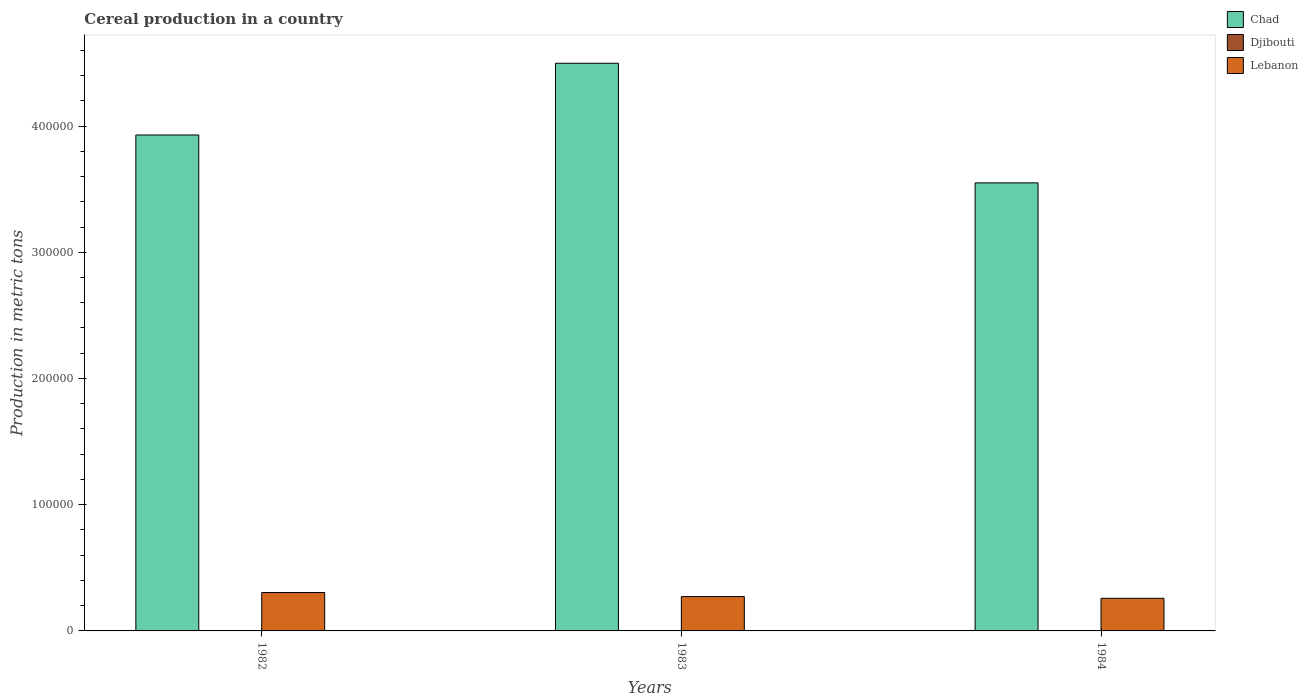How many groups of bars are there?
Provide a short and direct response. 3. Are the number of bars on each tick of the X-axis equal?
Offer a very short reply. Yes. What is the label of the 2nd group of bars from the left?
Give a very brief answer. 1983. What is the total cereal production in Chad in 1984?
Make the answer very short. 3.55e+05. Across all years, what is the maximum total cereal production in Djibouti?
Give a very brief answer. 7. What is the total total cereal production in Djibouti in the graph?
Your answer should be very brief. 17. What is the difference between the total cereal production in Chad in 1983 and that in 1984?
Make the answer very short. 9.48e+04. What is the difference between the total cereal production in Chad in 1982 and the total cereal production in Lebanon in 1983?
Your answer should be very brief. 3.66e+05. What is the average total cereal production in Chad per year?
Give a very brief answer. 3.99e+05. In the year 1982, what is the difference between the total cereal production in Chad and total cereal production in Djibouti?
Give a very brief answer. 3.93e+05. In how many years, is the total cereal production in Djibouti greater than 120000 metric tons?
Your response must be concise. 0. What is the ratio of the total cereal production in Chad in 1982 to that in 1984?
Your answer should be very brief. 1.11. What is the difference between the highest and the second highest total cereal production in Chad?
Give a very brief answer. 5.68e+04. What is the difference between the highest and the lowest total cereal production in Djibouti?
Ensure brevity in your answer.  2. Is the sum of the total cereal production in Chad in 1982 and 1983 greater than the maximum total cereal production in Lebanon across all years?
Keep it short and to the point. Yes. What does the 2nd bar from the left in 1982 represents?
Provide a short and direct response. Djibouti. What does the 2nd bar from the right in 1983 represents?
Ensure brevity in your answer.  Djibouti. Does the graph contain grids?
Make the answer very short. No. What is the title of the graph?
Make the answer very short. Cereal production in a country. What is the label or title of the X-axis?
Your answer should be very brief. Years. What is the label or title of the Y-axis?
Your answer should be very brief. Production in metric tons. What is the Production in metric tons in Chad in 1982?
Provide a short and direct response. 3.93e+05. What is the Production in metric tons in Djibouti in 1982?
Offer a very short reply. 5. What is the Production in metric tons in Lebanon in 1982?
Your response must be concise. 3.04e+04. What is the Production in metric tons of Chad in 1983?
Give a very brief answer. 4.50e+05. What is the Production in metric tons of Djibouti in 1983?
Your answer should be compact. 5. What is the Production in metric tons in Lebanon in 1983?
Keep it short and to the point. 2.72e+04. What is the Production in metric tons of Chad in 1984?
Provide a succinct answer. 3.55e+05. What is the Production in metric tons of Lebanon in 1984?
Make the answer very short. 2.58e+04. Across all years, what is the maximum Production in metric tons of Chad?
Provide a short and direct response. 4.50e+05. Across all years, what is the maximum Production in metric tons in Djibouti?
Ensure brevity in your answer.  7. Across all years, what is the maximum Production in metric tons in Lebanon?
Provide a succinct answer. 3.04e+04. Across all years, what is the minimum Production in metric tons of Chad?
Make the answer very short. 3.55e+05. Across all years, what is the minimum Production in metric tons in Djibouti?
Offer a terse response. 5. Across all years, what is the minimum Production in metric tons of Lebanon?
Provide a succinct answer. 2.58e+04. What is the total Production in metric tons of Chad in the graph?
Your answer should be very brief. 1.20e+06. What is the total Production in metric tons of Djibouti in the graph?
Give a very brief answer. 17. What is the total Production in metric tons of Lebanon in the graph?
Give a very brief answer. 8.35e+04. What is the difference between the Production in metric tons in Chad in 1982 and that in 1983?
Your response must be concise. -5.68e+04. What is the difference between the Production in metric tons in Djibouti in 1982 and that in 1983?
Keep it short and to the point. 0. What is the difference between the Production in metric tons of Lebanon in 1982 and that in 1983?
Keep it short and to the point. 3220. What is the difference between the Production in metric tons of Chad in 1982 and that in 1984?
Ensure brevity in your answer.  3.79e+04. What is the difference between the Production in metric tons of Djibouti in 1982 and that in 1984?
Give a very brief answer. -2. What is the difference between the Production in metric tons of Lebanon in 1982 and that in 1984?
Make the answer very short. 4589. What is the difference between the Production in metric tons of Chad in 1983 and that in 1984?
Offer a very short reply. 9.48e+04. What is the difference between the Production in metric tons of Lebanon in 1983 and that in 1984?
Your answer should be very brief. 1369. What is the difference between the Production in metric tons of Chad in 1982 and the Production in metric tons of Djibouti in 1983?
Provide a short and direct response. 3.93e+05. What is the difference between the Production in metric tons in Chad in 1982 and the Production in metric tons in Lebanon in 1983?
Your answer should be very brief. 3.66e+05. What is the difference between the Production in metric tons of Djibouti in 1982 and the Production in metric tons of Lebanon in 1983?
Ensure brevity in your answer.  -2.72e+04. What is the difference between the Production in metric tons in Chad in 1982 and the Production in metric tons in Djibouti in 1984?
Your answer should be very brief. 3.93e+05. What is the difference between the Production in metric tons in Chad in 1982 and the Production in metric tons in Lebanon in 1984?
Keep it short and to the point. 3.67e+05. What is the difference between the Production in metric tons in Djibouti in 1982 and the Production in metric tons in Lebanon in 1984?
Your answer should be compact. -2.58e+04. What is the difference between the Production in metric tons of Chad in 1983 and the Production in metric tons of Djibouti in 1984?
Provide a succinct answer. 4.50e+05. What is the difference between the Production in metric tons of Chad in 1983 and the Production in metric tons of Lebanon in 1984?
Your response must be concise. 4.24e+05. What is the difference between the Production in metric tons in Djibouti in 1983 and the Production in metric tons in Lebanon in 1984?
Make the answer very short. -2.58e+04. What is the average Production in metric tons in Chad per year?
Offer a very short reply. 3.99e+05. What is the average Production in metric tons of Djibouti per year?
Your answer should be compact. 5.67. What is the average Production in metric tons of Lebanon per year?
Keep it short and to the point. 2.78e+04. In the year 1982, what is the difference between the Production in metric tons of Chad and Production in metric tons of Djibouti?
Provide a succinct answer. 3.93e+05. In the year 1982, what is the difference between the Production in metric tons in Chad and Production in metric tons in Lebanon?
Your answer should be very brief. 3.62e+05. In the year 1982, what is the difference between the Production in metric tons in Djibouti and Production in metric tons in Lebanon?
Keep it short and to the point. -3.04e+04. In the year 1983, what is the difference between the Production in metric tons in Chad and Production in metric tons in Djibouti?
Provide a succinct answer. 4.50e+05. In the year 1983, what is the difference between the Production in metric tons of Chad and Production in metric tons of Lebanon?
Provide a succinct answer. 4.23e+05. In the year 1983, what is the difference between the Production in metric tons of Djibouti and Production in metric tons of Lebanon?
Make the answer very short. -2.72e+04. In the year 1984, what is the difference between the Production in metric tons of Chad and Production in metric tons of Djibouti?
Your response must be concise. 3.55e+05. In the year 1984, what is the difference between the Production in metric tons of Chad and Production in metric tons of Lebanon?
Provide a short and direct response. 3.29e+05. In the year 1984, what is the difference between the Production in metric tons of Djibouti and Production in metric tons of Lebanon?
Provide a short and direct response. -2.58e+04. What is the ratio of the Production in metric tons of Chad in 1982 to that in 1983?
Provide a short and direct response. 0.87. What is the ratio of the Production in metric tons of Lebanon in 1982 to that in 1983?
Offer a terse response. 1.12. What is the ratio of the Production in metric tons in Chad in 1982 to that in 1984?
Provide a short and direct response. 1.11. What is the ratio of the Production in metric tons in Djibouti in 1982 to that in 1984?
Your response must be concise. 0.71. What is the ratio of the Production in metric tons of Lebanon in 1982 to that in 1984?
Your response must be concise. 1.18. What is the ratio of the Production in metric tons in Chad in 1983 to that in 1984?
Provide a succinct answer. 1.27. What is the ratio of the Production in metric tons of Djibouti in 1983 to that in 1984?
Provide a succinct answer. 0.71. What is the ratio of the Production in metric tons of Lebanon in 1983 to that in 1984?
Keep it short and to the point. 1.05. What is the difference between the highest and the second highest Production in metric tons in Chad?
Make the answer very short. 5.68e+04. What is the difference between the highest and the second highest Production in metric tons in Lebanon?
Provide a short and direct response. 3220. What is the difference between the highest and the lowest Production in metric tons of Chad?
Your answer should be compact. 9.48e+04. What is the difference between the highest and the lowest Production in metric tons in Lebanon?
Give a very brief answer. 4589. 